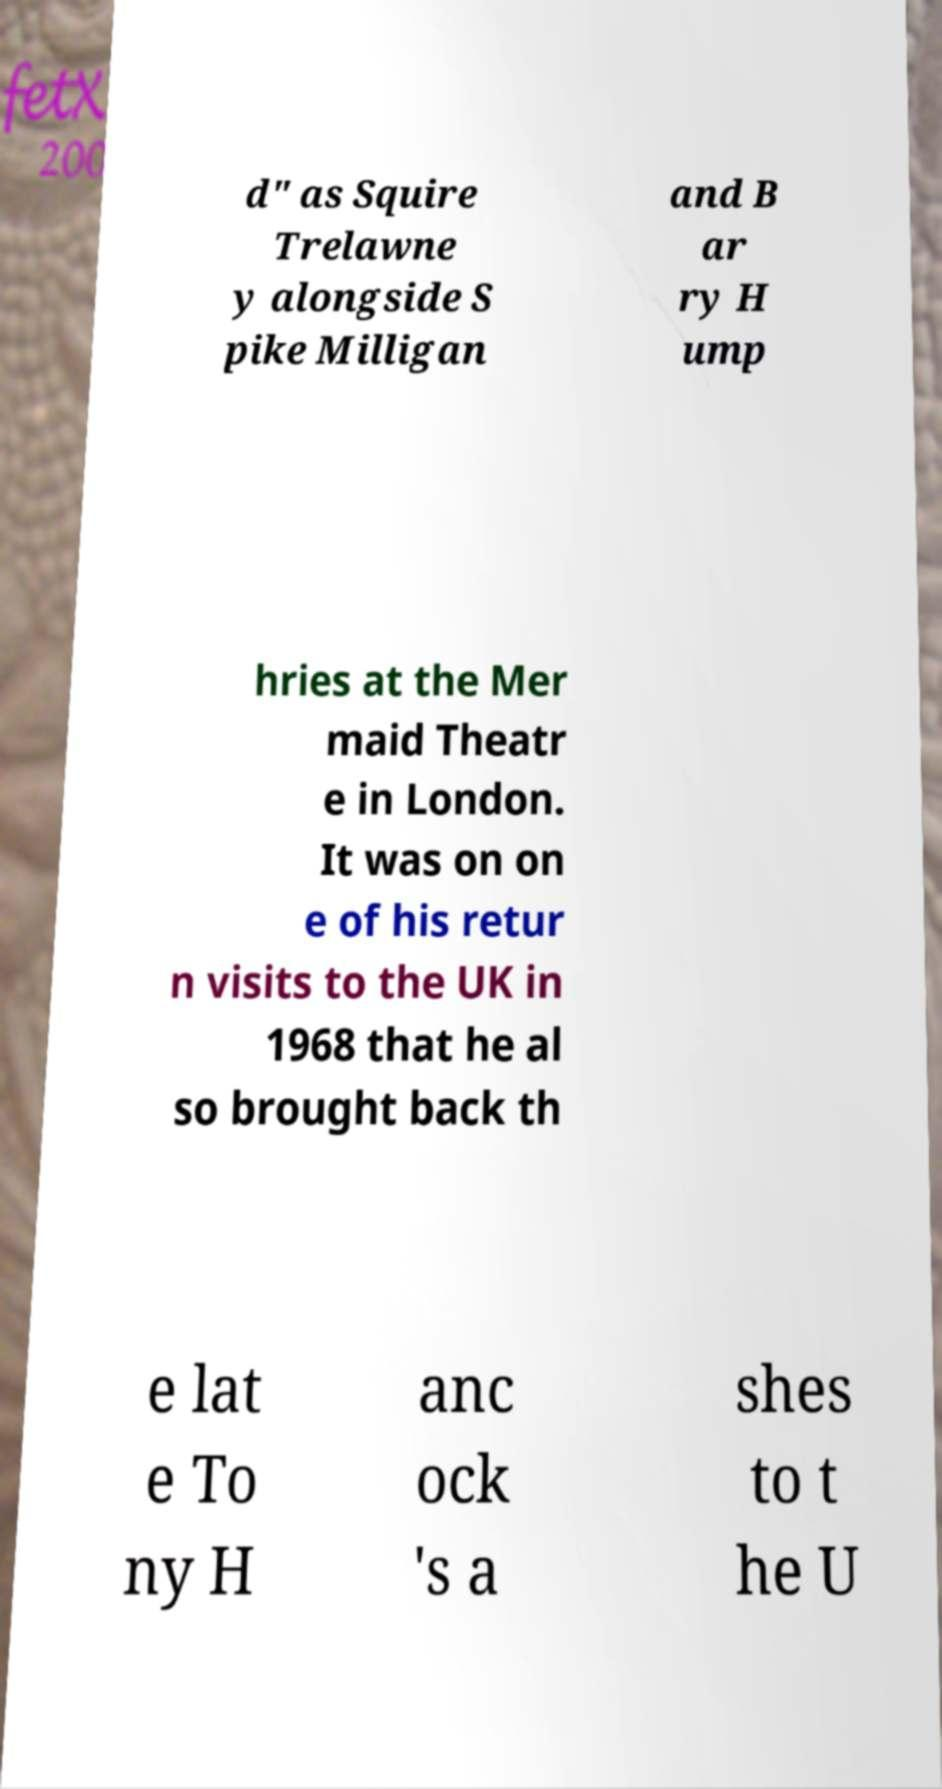Can you accurately transcribe the text from the provided image for me? d" as Squire Trelawne y alongside S pike Milligan and B ar ry H ump hries at the Mer maid Theatr e in London. It was on on e of his retur n visits to the UK in 1968 that he al so brought back th e lat e To ny H anc ock 's a shes to t he U 